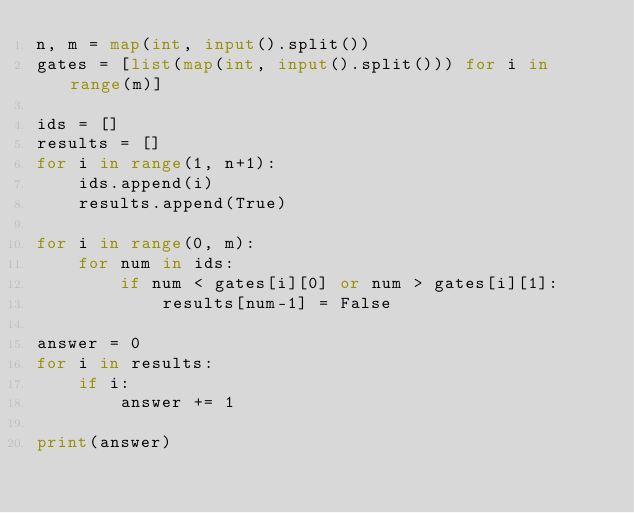Convert code to text. <code><loc_0><loc_0><loc_500><loc_500><_Python_>n, m = map(int, input().split())
gates = [list(map(int, input().split())) for i in range(m)]

ids = []
results = []
for i in range(1, n+1):
    ids.append(i)
    results.append(True)

for i in range(0, m):
    for num in ids:
        if num < gates[i][0] or num > gates[i][1]:
            results[num-1] = False

answer = 0
for i in results:
    if i:
        answer += 1

print(answer)
</code> 